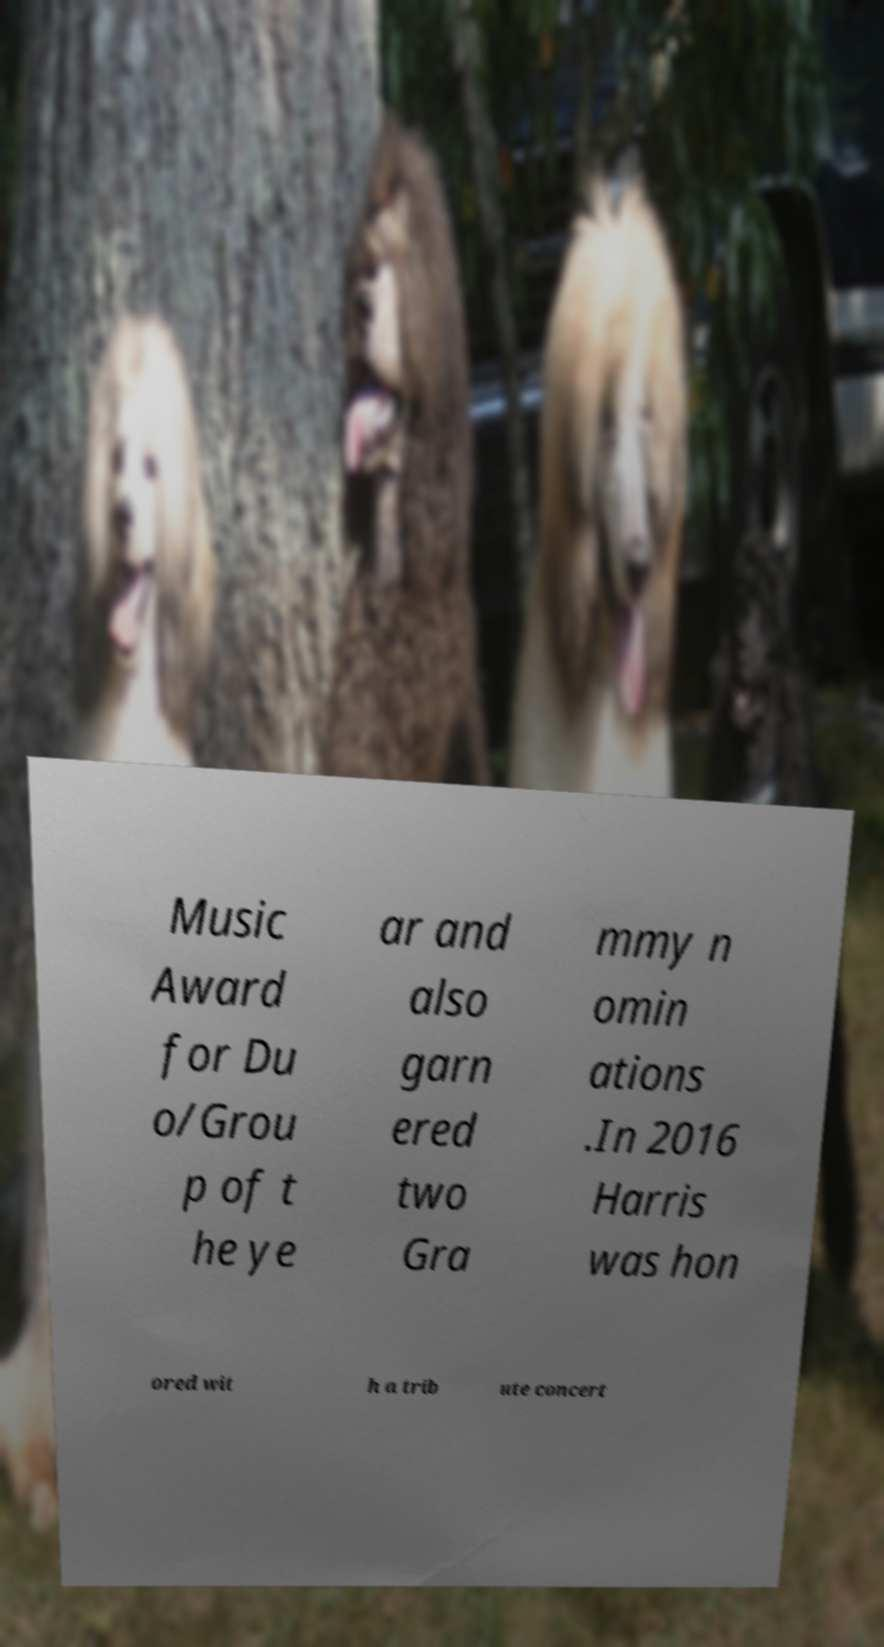For documentation purposes, I need the text within this image transcribed. Could you provide that? Music Award for Du o/Grou p of t he ye ar and also garn ered two Gra mmy n omin ations .In 2016 Harris was hon ored wit h a trib ute concert 